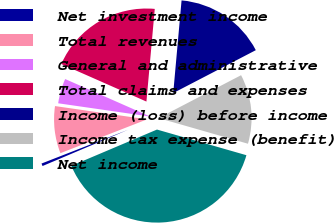<chart> <loc_0><loc_0><loc_500><loc_500><pie_chart><fcel>Net investment income<fcel>Total revenues<fcel>General and administrative<fcel>Total claims and expenses<fcel>Income (loss) before income<fcel>Income tax expense (benefit)<fcel>Net income<nl><fcel>0.46%<fcel>8.2%<fcel>4.33%<fcel>19.82%<fcel>15.95%<fcel>12.07%<fcel>39.18%<nl></chart> 